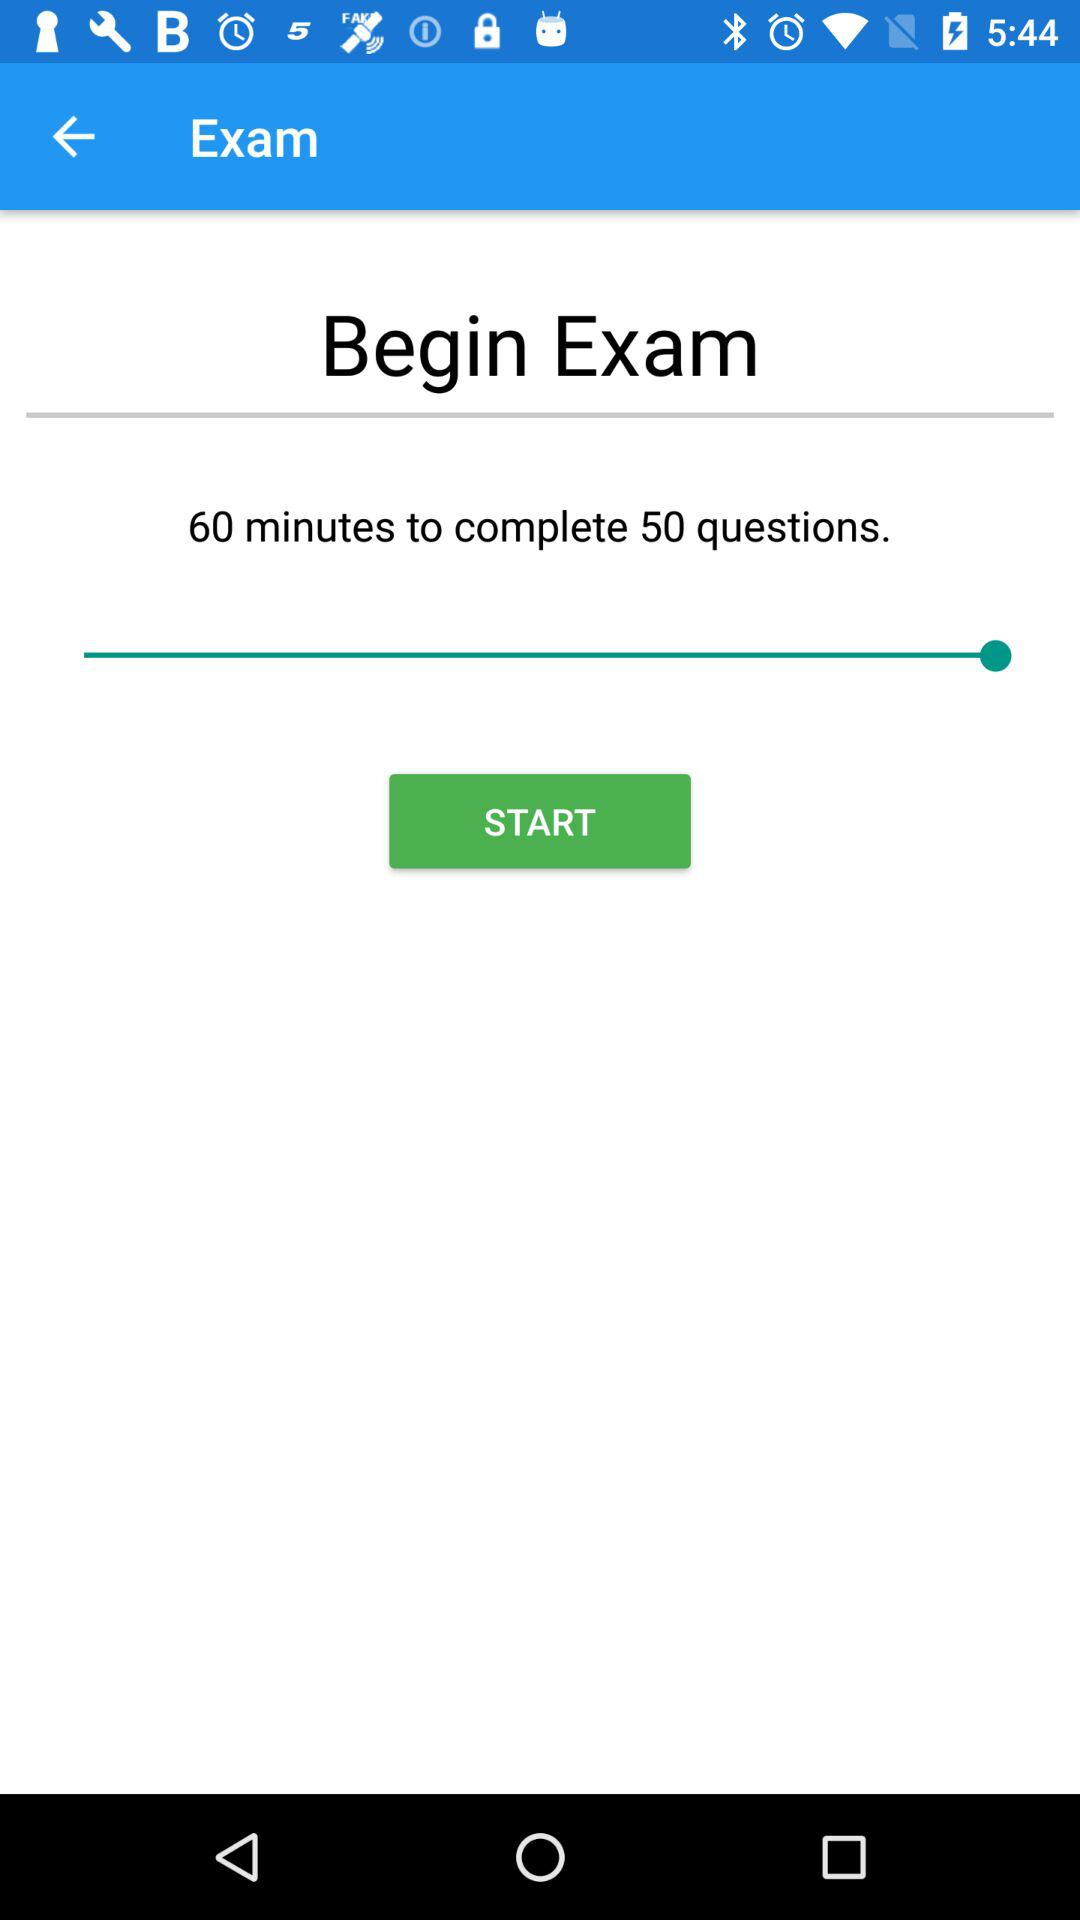What is the total number of questions? The total number of questions is 50. 